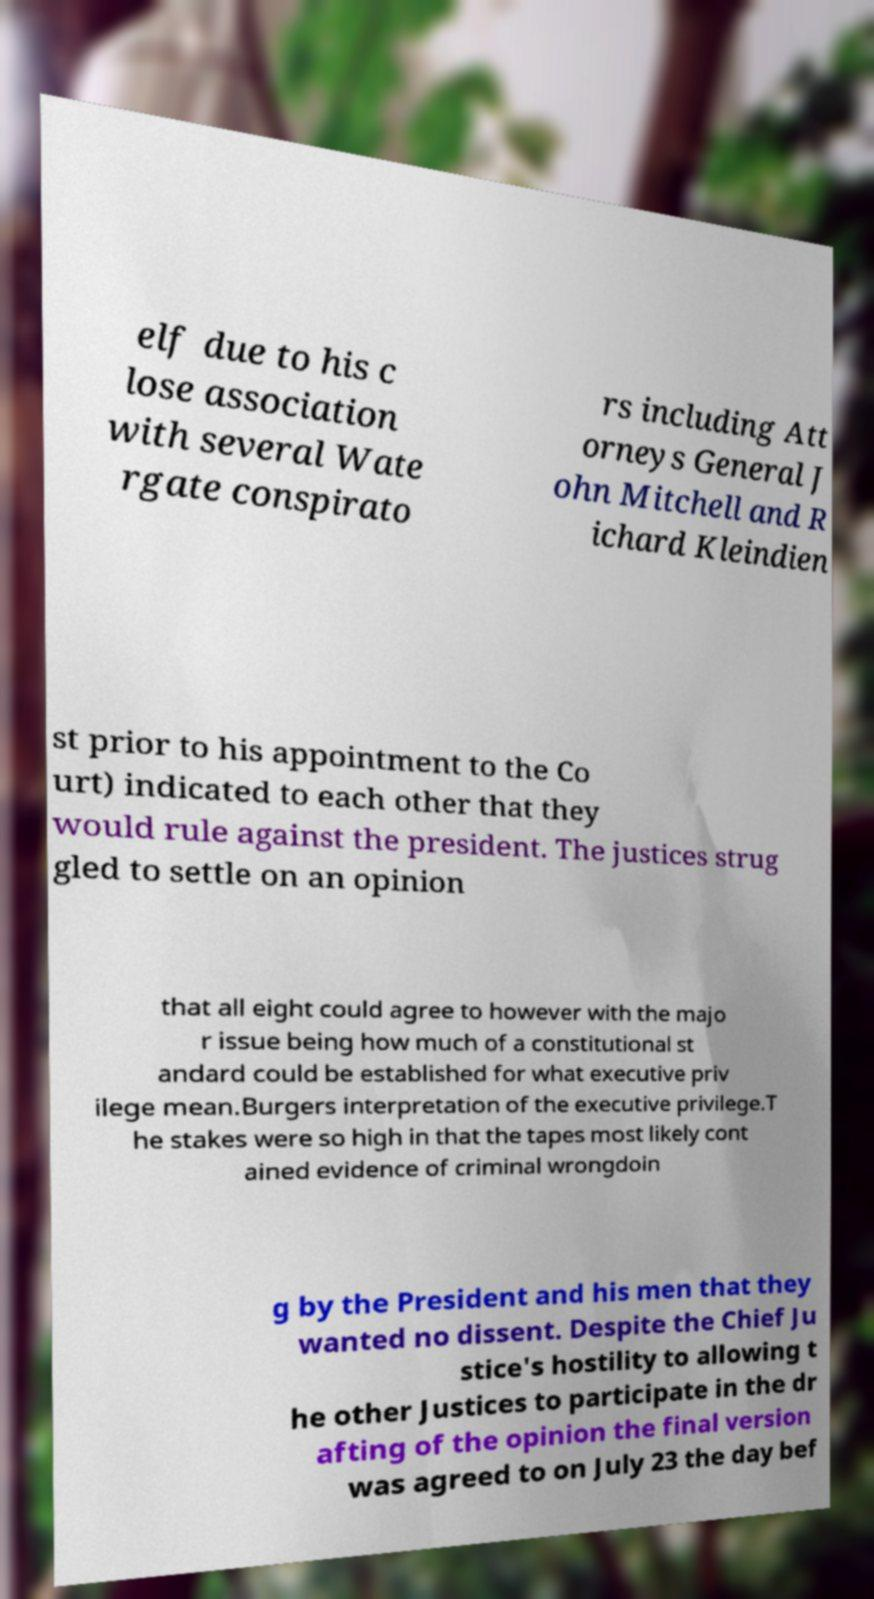What messages or text are displayed in this image? I need them in a readable, typed format. elf due to his c lose association with several Wate rgate conspirato rs including Att orneys General J ohn Mitchell and R ichard Kleindien st prior to his appointment to the Co urt) indicated to each other that they would rule against the president. The justices strug gled to settle on an opinion that all eight could agree to however with the majo r issue being how much of a constitutional st andard could be established for what executive priv ilege mean.Burgers interpretation of the executive privilege.T he stakes were so high in that the tapes most likely cont ained evidence of criminal wrongdoin g by the President and his men that they wanted no dissent. Despite the Chief Ju stice's hostility to allowing t he other Justices to participate in the dr afting of the opinion the final version was agreed to on July 23 the day bef 